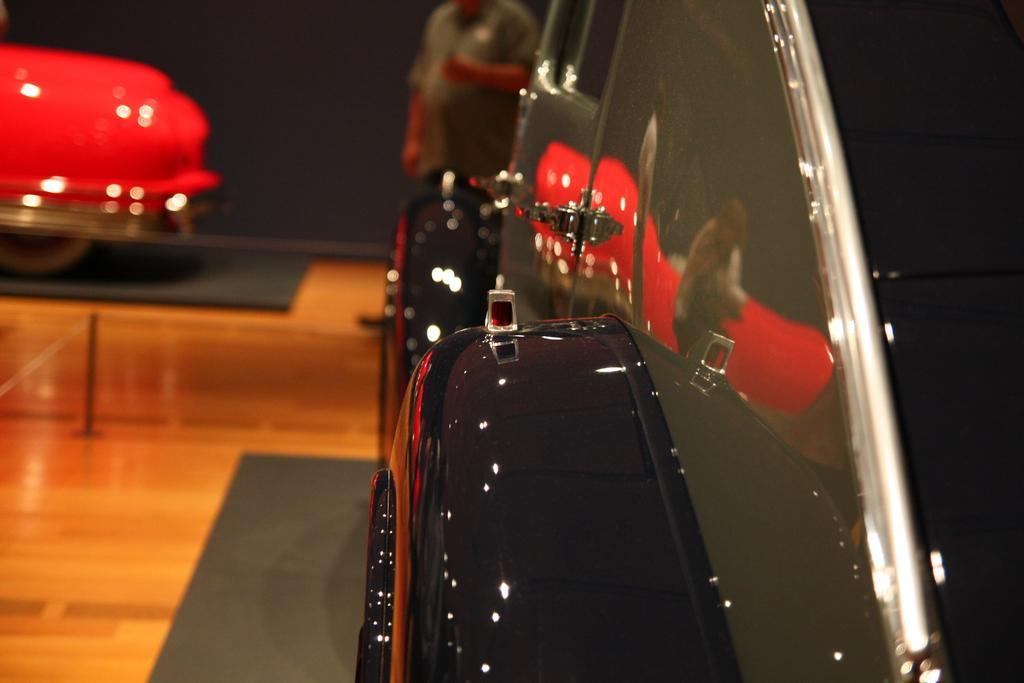Please provide a concise description of this image. In this picture we can see vehicles. On the floor we can see carpets and on the left side there is a pole. In the background we can see a man is standing. 